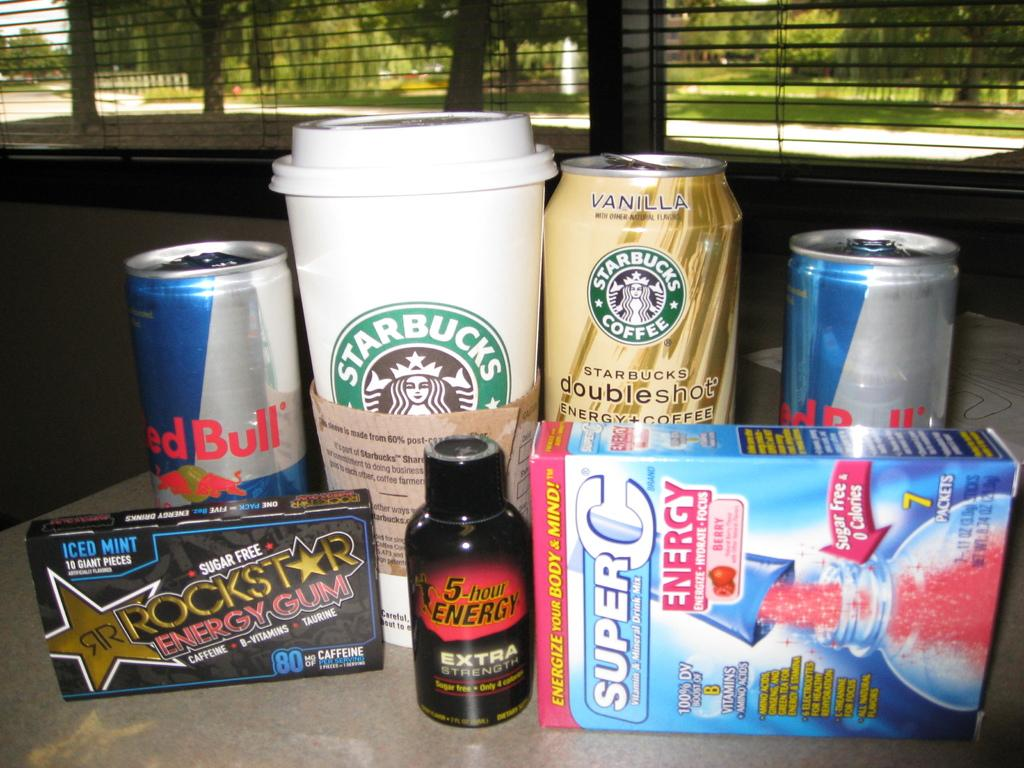<image>
Share a concise interpretation of the image provided. A table with an assortment of energy drinks including Red Bull, Starbucks and Rockstar beverages and dry mixes. 